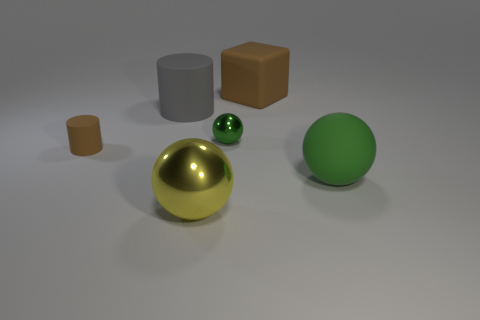Subtract all large matte balls. How many balls are left? 2 Subtract all yellow spheres. How many spheres are left? 2 Subtract all cubes. How many objects are left? 5 Subtract 2 balls. How many balls are left? 1 Subtract all small cyan rubber cubes. Subtract all tiny green objects. How many objects are left? 5 Add 4 big green balls. How many big green balls are left? 5 Add 1 big red spheres. How many big red spheres exist? 1 Add 1 tiny cylinders. How many objects exist? 7 Subtract 0 green blocks. How many objects are left? 6 Subtract all green cubes. Subtract all purple balls. How many cubes are left? 1 